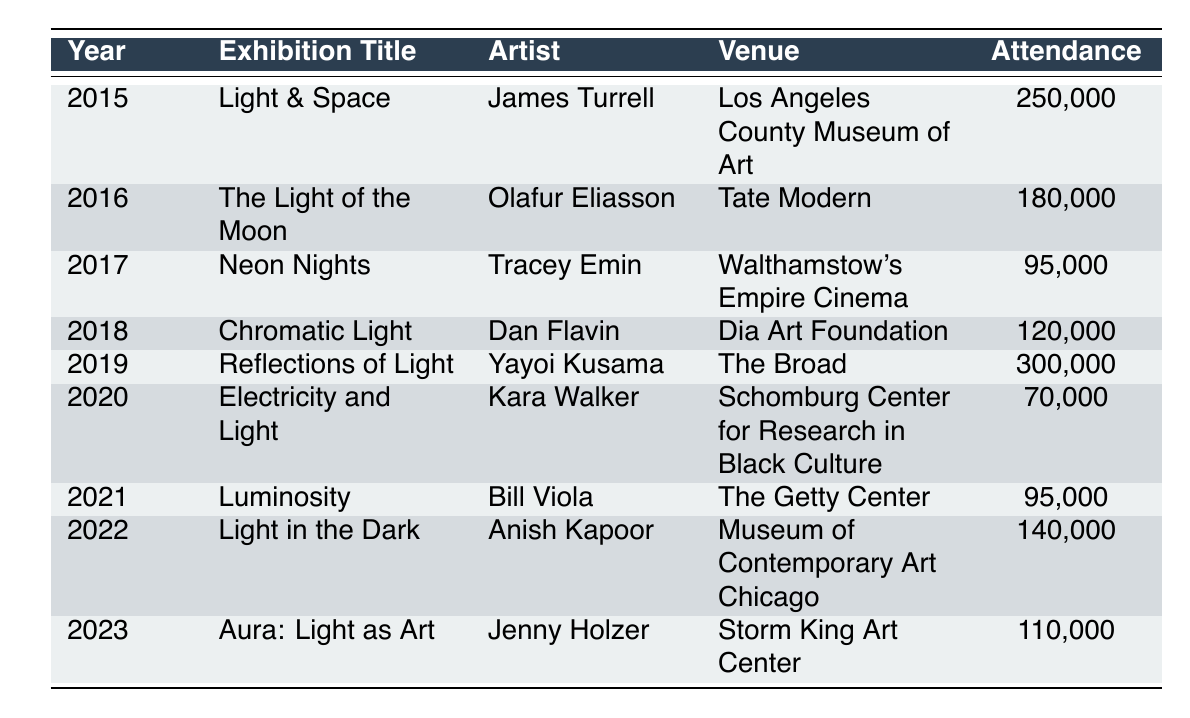What was the highest exhibition attendance recorded in the table? By examining the attendance figures for each exhibition listed, the highest number is 300,000 for "Reflections of Light" by Yayoi Kusama in 2019.
Answer: 300,000 Which artist had an exhibition at the Tate Modern? The table shows that Olafur Eliasson had an exhibition titled "The Light of the Moon" at the Tate Modern in 2016.
Answer: Olafur Eliasson What was the total attendance for light-themed exhibitions from 2015 to 2023? Adding the attendance figures for all the exhibitions: 250000 + 180000 + 95000 + 120000 + 300000 + 70000 + 95000 + 140000 + 110000 = 1,465,000.
Answer: 1,465,000 Which year had the lowest exhibition attendance? The attendance figures show 70,000 for "Electricity and Light" by Kara Walker in 2020, which is the lowest among all years listed.
Answer: 2020 What is the average attendance for the exhibitions in the years 2019 and 2020? The attendances for 2019 is 300,000 and for 2020 is 70,000. The average is (300000 + 70000) / 2 = 185,000.
Answer: 185,000 Did Anish Kapoor have the highest attendance figure in his exhibition? Comparing Anish Kapoor's exhibition "Light in the Dark" in 2022 with all others, the attendance of 140,000 is lower than "Reflections of Light" in 2019 (300,000), hence it is not the highest.
Answer: No Which two artists' exhibitions had attendance figures below 100,000? Tracey Emin's "Neon Nights" (95,000) and Kara Walker's "Electricity and Light" (70,000) both had attendance figures below 100,000, as confirmed by their respective attendance numbers.
Answer: Tracey Emin and Kara Walker What is the difference in attendance between the exhibitions in 2015 and 2022? The attendance in 2015 is 250,000 and in 2022 is 140,000. The difference is 250,000 - 140,000 = 110,000.
Answer: 110,000 In which venues were the exhibitions held in alternating years? Reviewing the table, Los Angeles County Museum of Art (2015), Walthamstow's Empire Cinema (2017), Schomburg Center (2020), and Storm King Art Center (2023) can be seen as alternates.
Answer: Los Angeles County Museum of Art, Walthamstow's Empire Cinema, Schomburg Center, Storm King Art Center How many exhibitions had an attendance higher than 100,000? From the table, exhibitions "Light & Space" (250,000), "The Light of the Moon" (180,000), "Reflections of Light" (300,000), "Chromatic Light" (120,000), and "Light in the Dark" (140,000) had figures above 100,000, totaling to five exhibitions.
Answer: 5 